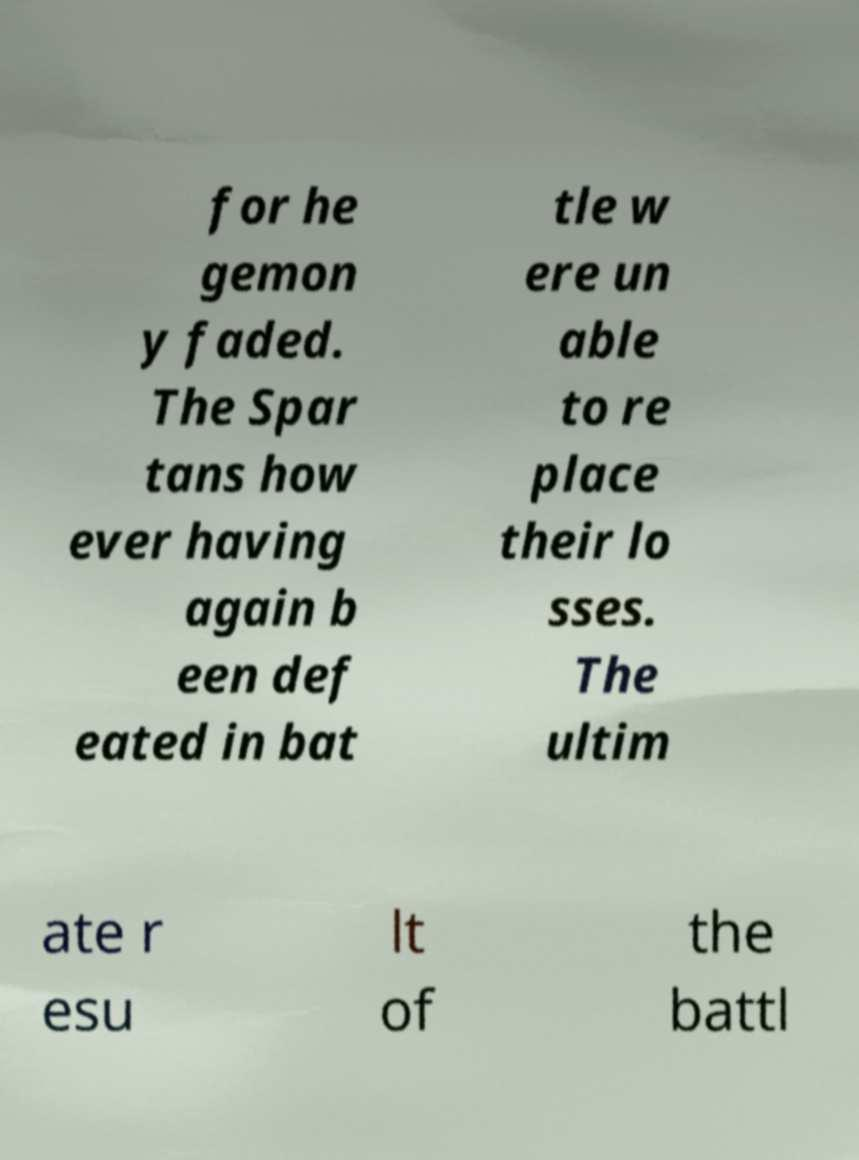There's text embedded in this image that I need extracted. Can you transcribe it verbatim? for he gemon y faded. The Spar tans how ever having again b een def eated in bat tle w ere un able to re place their lo sses. The ultim ate r esu lt of the battl 